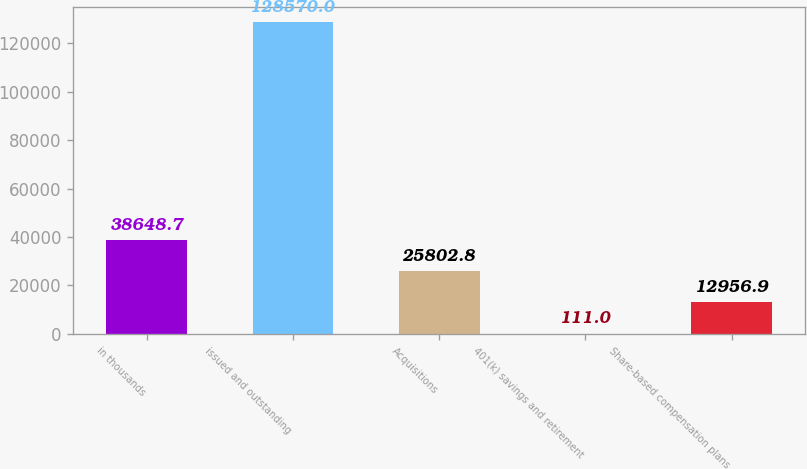Convert chart to OTSL. <chart><loc_0><loc_0><loc_500><loc_500><bar_chart><fcel>in thousands<fcel>issued and outstanding<fcel>Acquisitions<fcel>401(k) savings and retirement<fcel>Share-based compensation plans<nl><fcel>38648.7<fcel>128570<fcel>25802.8<fcel>111<fcel>12956.9<nl></chart> 